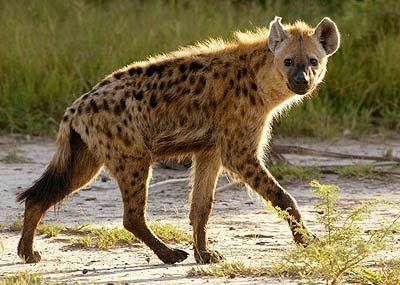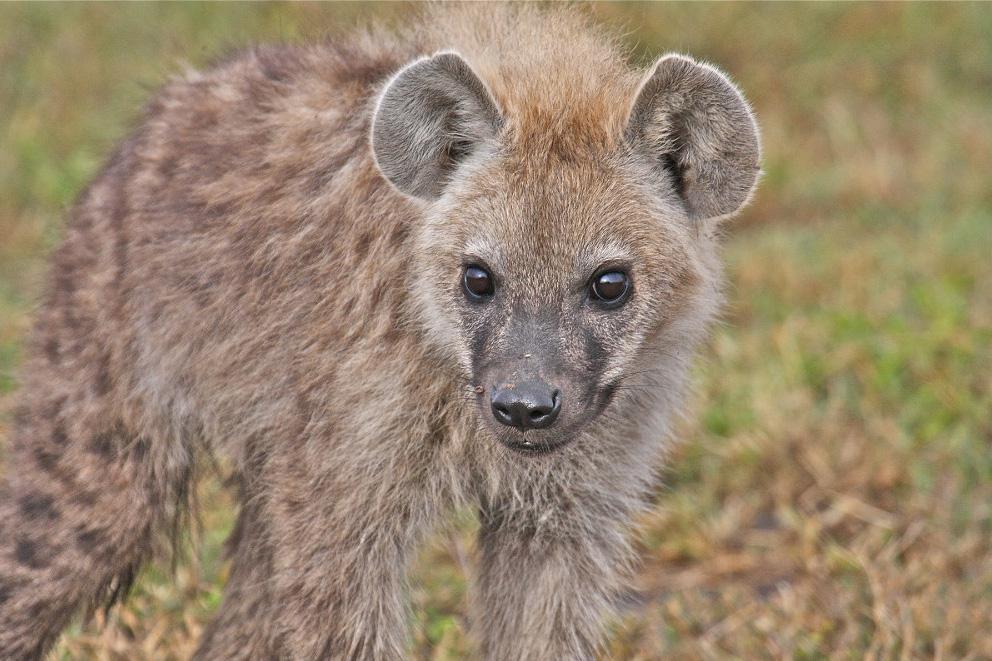The first image is the image on the left, the second image is the image on the right. For the images shown, is this caption "No hyena is facing left." true? Answer yes or no. Yes. 